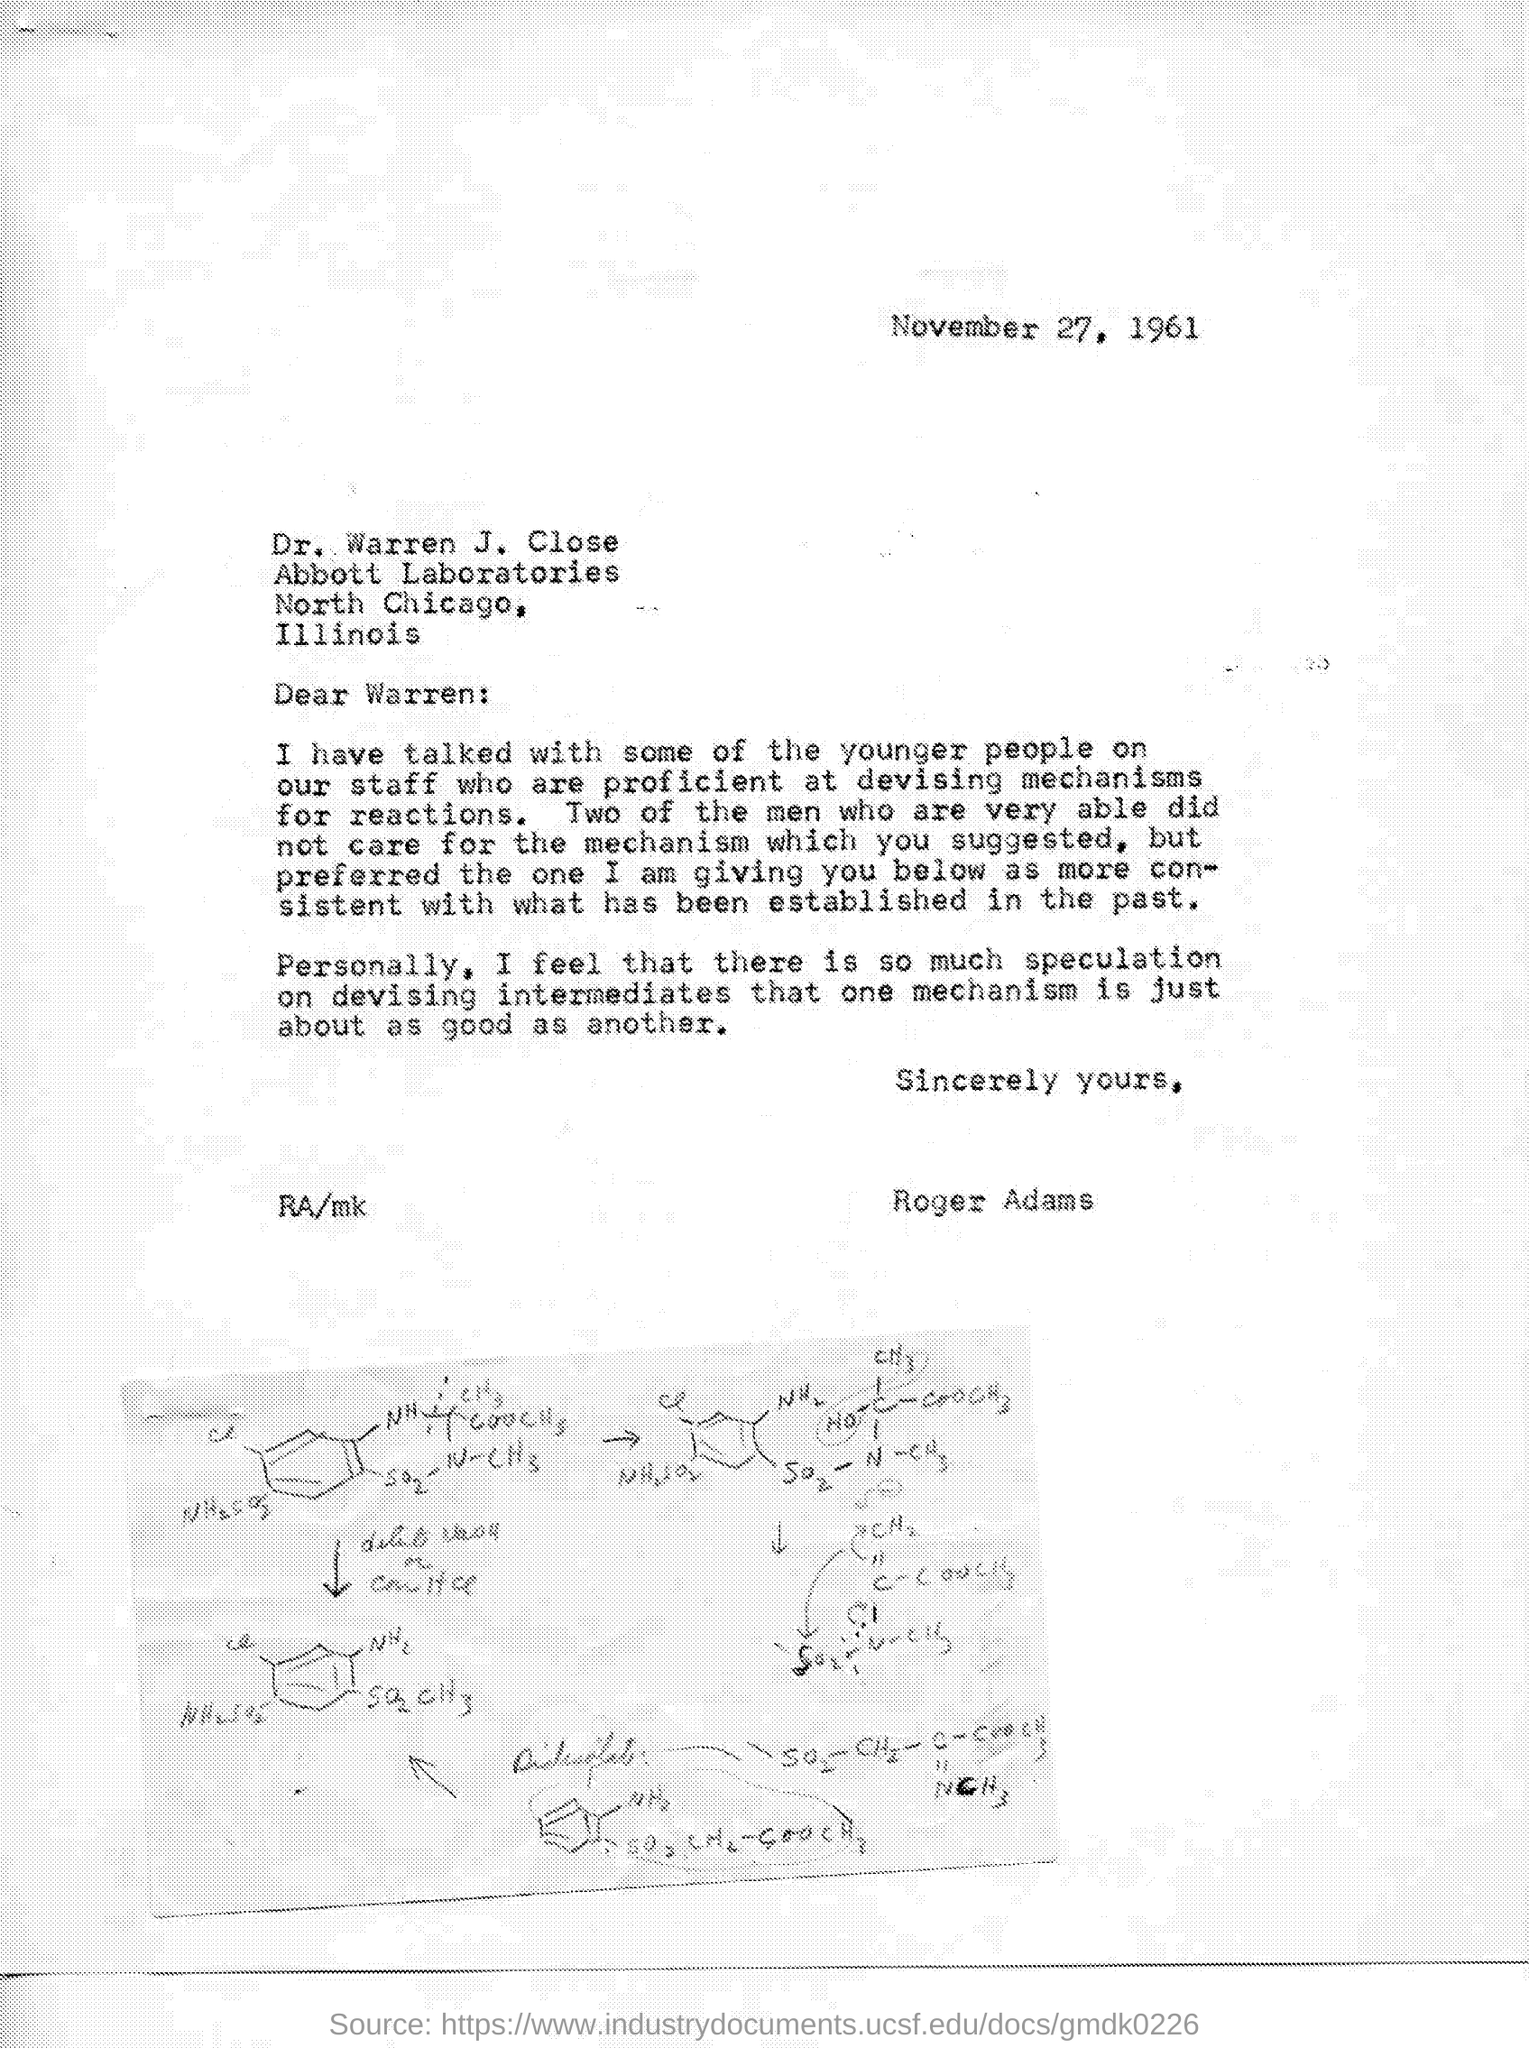When is the letter dated?
Keep it short and to the point. November 27, 1961. To whom is the letter addressed?
Provide a succinct answer. Warren. Who is the sender?
Offer a terse response. Roger Adams. 